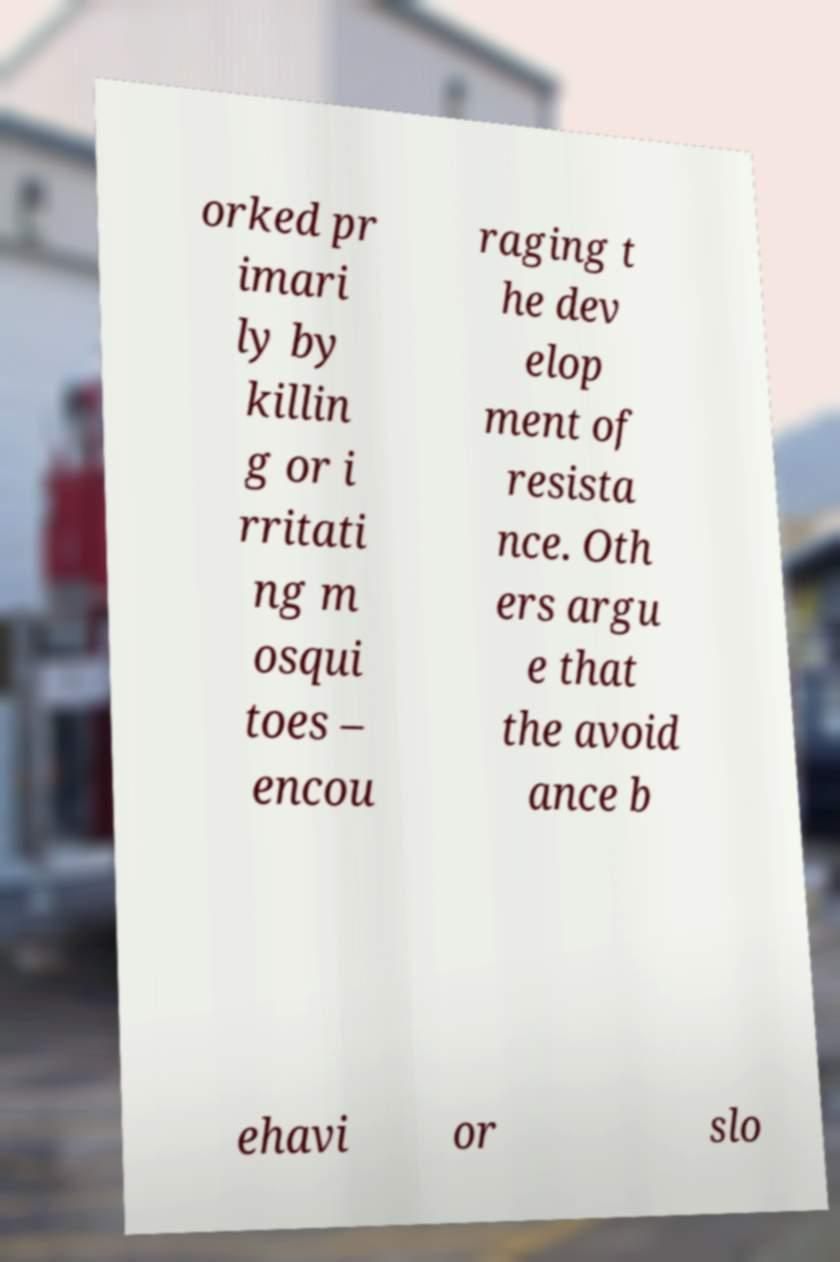What messages or text are displayed in this image? I need them in a readable, typed format. orked pr imari ly by killin g or i rritati ng m osqui toes – encou raging t he dev elop ment of resista nce. Oth ers argu e that the avoid ance b ehavi or slo 